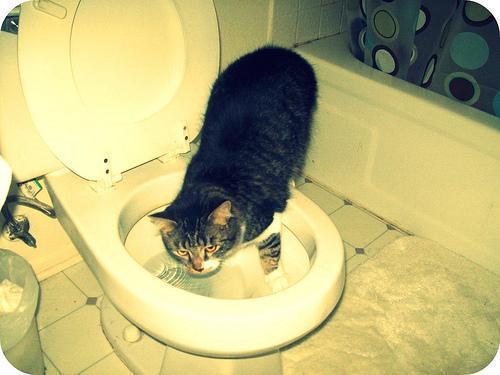How many paws does the cat have in the toilet?
Give a very brief answer. 2. How many people have theirs shirts off?
Give a very brief answer. 0. 